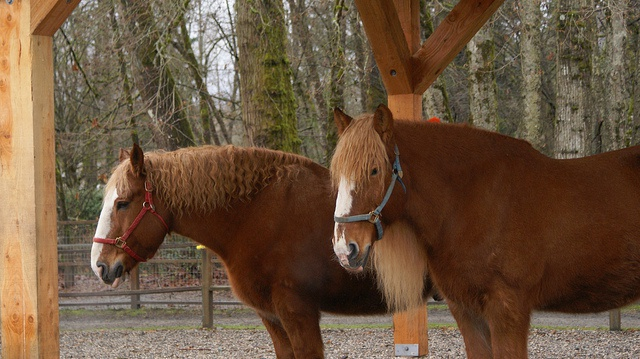Describe the objects in this image and their specific colors. I can see horse in brown, maroon, black, and gray tones and horse in brown, maroon, black, and gray tones in this image. 